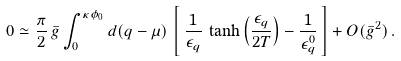Convert formula to latex. <formula><loc_0><loc_0><loc_500><loc_500>0 \simeq \frac { \pi } { 2 } \, \bar { g } \int _ { 0 } ^ { \kappa \phi _ { 0 } } d ( q - \mu ) \, \left [ \, \frac { 1 } { \epsilon _ { q } } \, \tanh \left ( \frac { \epsilon _ { q } } { 2 T } \right ) - \frac { 1 } { \epsilon _ { q } ^ { 0 } } \, \right ] + O ( \bar { g } ^ { 2 } ) \, .</formula> 